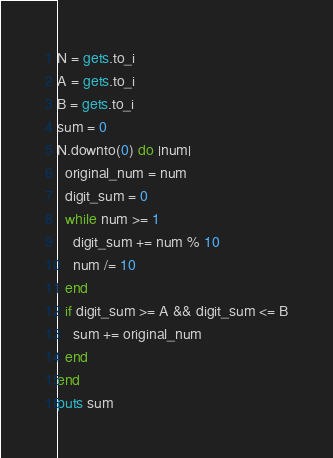<code> <loc_0><loc_0><loc_500><loc_500><_Ruby_>N = gets.to_i
A = gets.to_i
B = gets.to_i
sum = 0
N.downto(0) do |num|
  original_num = num
  digit_sum = 0
  while num >= 1
    digit_sum += num % 10
    num /= 10
  end
  if digit_sum >= A && digit_sum <= B
    sum += original_num
  end
end
puts sum</code> 